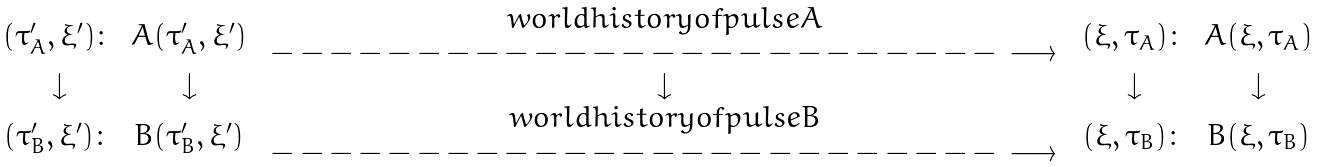<formula> <loc_0><loc_0><loc_500><loc_500>\begin{array} { c c c c c } ( \tau ^ { \prime } _ { A } , \xi ^ { \prime } ) \colon & A ( \tau ^ { \prime } _ { A } , \xi ^ { \prime } ) & \begin{array} { c } w o r l d h i s t o r y o f p u l s e A \\ - - - - - - - - - - - - - - - - - - - - - - - - - \, \longrightarrow \\ \end{array} & ( \xi , \tau _ { A } ) \colon & A ( \xi , \tau _ { A } ) \\ \downarrow & \downarrow & \downarrow & \downarrow & \downarrow \\ ( \tau ^ { \prime } _ { B } , \xi ^ { \prime } ) \colon & B ( \tau ^ { \prime } _ { B } , \xi ^ { \prime } ) & \begin{array} { c } w o r l d h i s t o r y o f p u l s e B \\ - - - - - - - - - - - - - - - - - - - - - - - - - \, \longrightarrow \\ \end{array} & ( \xi , \tau _ { B } ) \colon & B ( \xi , \tau _ { B } ) \end{array}</formula> 